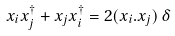Convert formula to latex. <formula><loc_0><loc_0><loc_500><loc_500>x _ { i } x ^ { \dagger } _ { j } + x _ { j } x ^ { \dagger } _ { i } = 2 ( x _ { i } . x _ { j } ) \, \delta</formula> 